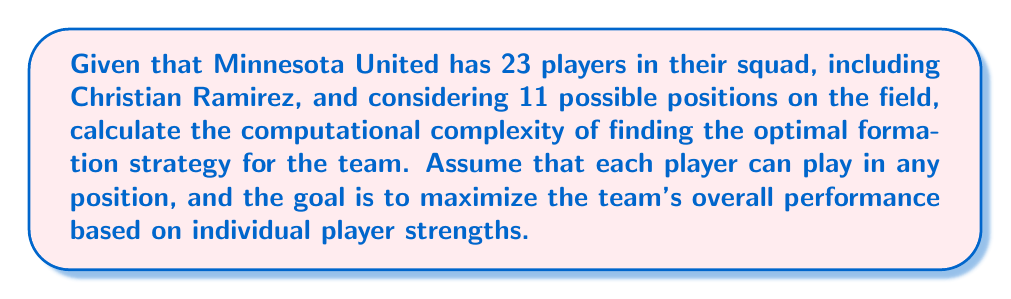Can you answer this question? To solve this problem, we need to consider the following steps:

1. First, we need to understand that this is a combinatorial optimization problem.

2. The total number of possible team formations is the number of ways to select 11 players from 23 and assign them to 11 positions. This can be calculated as:

   $$\binom{23}{11} \cdot 11!$$

   Where $\binom{23}{11}$ is the number of ways to choose 11 players from 23, and 11! is the number of ways to arrange these 11 players in the positions.

3. Calculating this:
   $$\binom{23}{11} \cdot 11! = 1,352,078 \cdot 39,916,800 = 53,990,604,289,600$$

4. To find the optimal formation, we would need to evaluate each of these possibilities.

5. Assuming we have a function to evaluate the performance of a given formation in constant time, the time complexity of checking all formations would be O(53,990,604,289,600), which we can simplify to O($2^{23}$).

6. This is an exponential time complexity, which falls into the class of NP-hard problems.

7. In practice, heuristic methods or approximation algorithms would be used to find a near-optimal solution in a reasonable time, as checking all possibilities is computationally infeasible for larger teams or leagues.
Answer: The computational complexity of finding the optimal formation strategy for Minnesota United with 23 players is O($2^{23}$), which is exponential time complexity. 